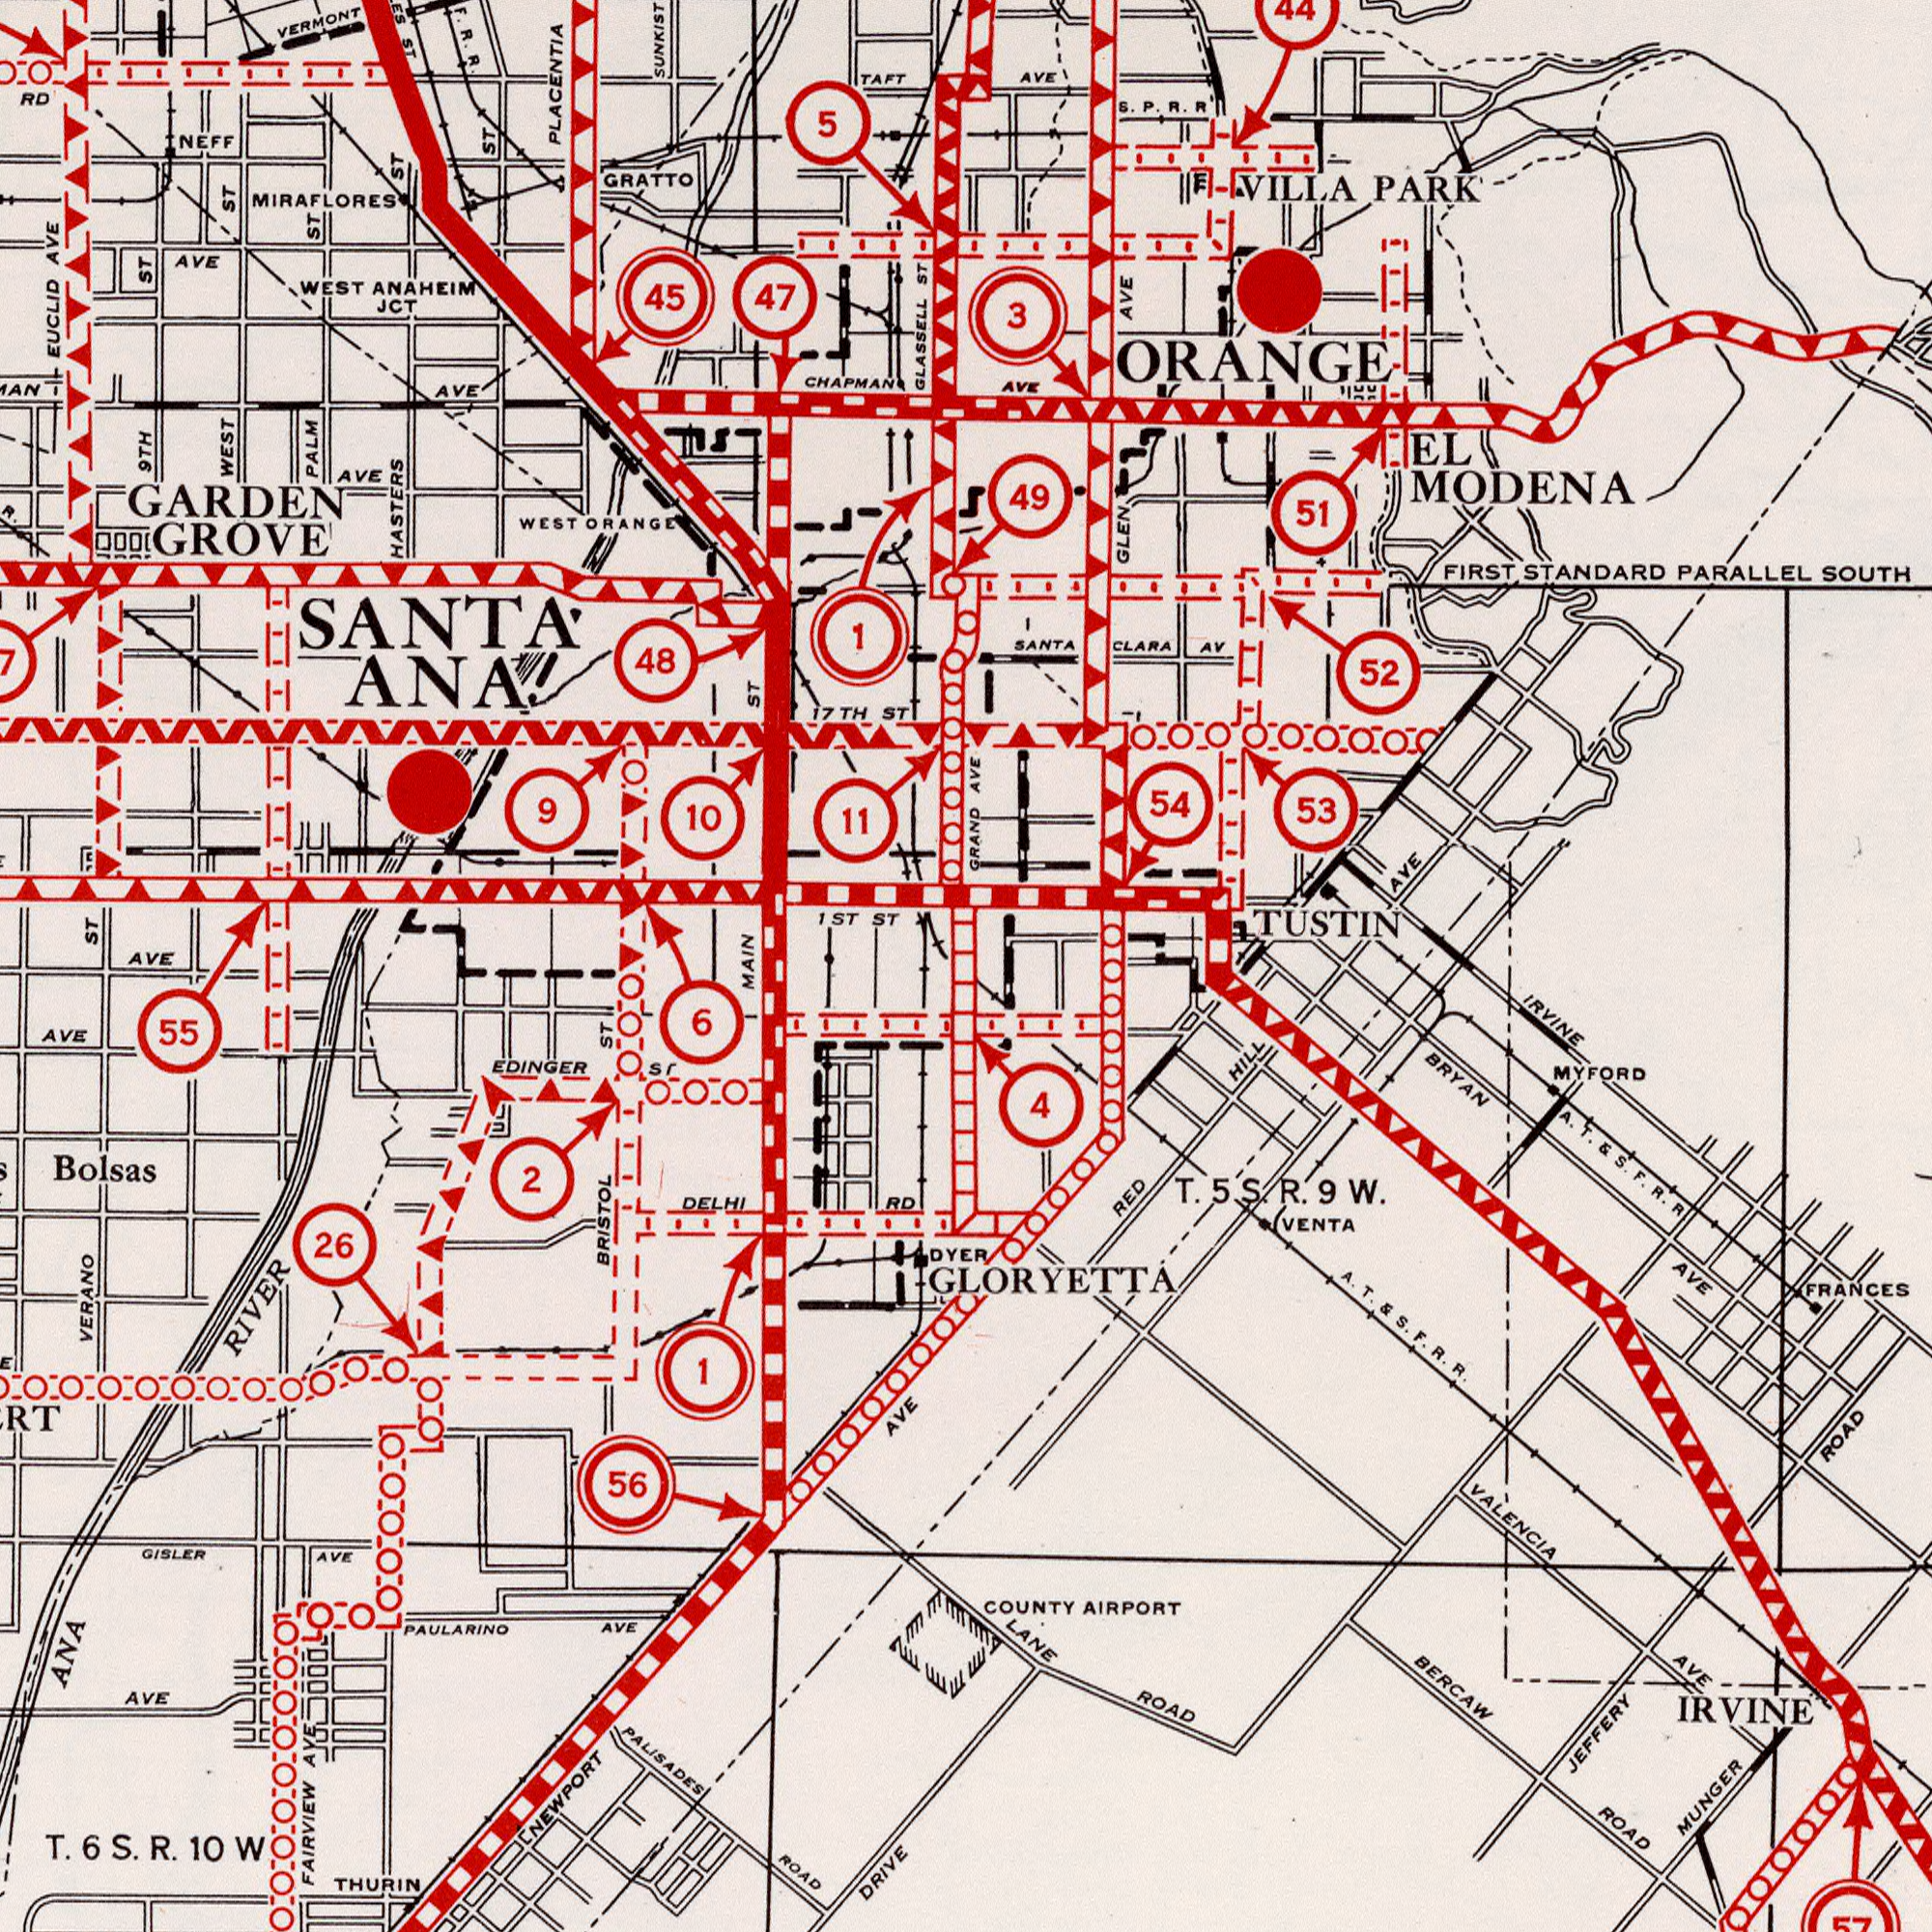What text is shown in the bottom-right quadrant? RED HILL DYER IRVINE MUNGER JEFFERY ROAD FRANCES IRVINE BERCAW ROAD BRYAN AVE COUNTY AIRPORT VENTA LANE ROAD VALENCIA AVE 4 A. T. E S. F. R. R GLORYETTA 57 MYFORD A. T. & S. F. R. R. T. 5 S. R. 9 W. What text appears in the top-right area of the image? AVE AVE FIRST STANDARD PARALLEL SOUTH EL MODENA VIILA PARK 53 54 52 3 GRAND AVE AVE GLEN AVE ORANGE SANTA CLARA AV 49 51 44 TUSTIN S. P. R. R What text appears in the top-left area of the image? SANTA ANA GLASSELL ST PLACENTIA HASTERS ST EUCLID AVE 1ST ST 45 47 GRATTO WEST ANAHEIM JCT WEST ST AVE ST PALM ST 11 48 AVE 1 ST VERMONT 10 F. R. R. AVE 9TH ST RD CHAPMAN NEFF TAFT GARDEN GROVE 9 AVE 17TH ST MIRAFLORES 5 7 WEST ORANGE ST MAIN ST What text appears in the bottom-left area of the image? VERANO NEWPORT AVE FAIRVIEW AVE BRISTOL ST PALISADES ROAD DRIVE ANA RIVER 26 AVE 55 56 EDINGER ST T. 6S. R. 10W GISLER AVE PAULARINO AVE AVE Bolsas DELHI RD THURIN 2 1 6 